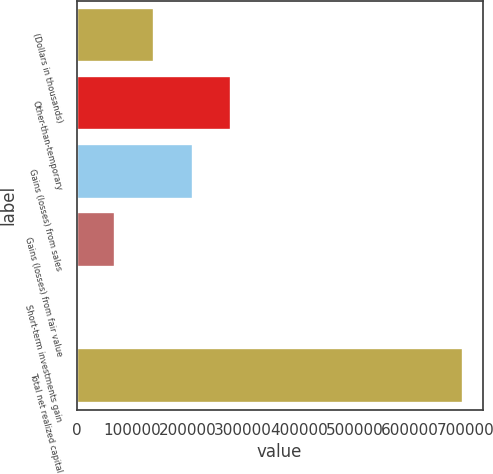<chart> <loc_0><loc_0><loc_500><loc_500><bar_chart><fcel>(Dollars in thousands)<fcel>Other-than-temporary<fcel>Gains (losses) from sales<fcel>Gains (losses) from fair value<fcel>Short-term investments gain<fcel>Total net realized capital<nl><fcel>139271<fcel>278411<fcel>208841<fcel>69700.9<fcel>131<fcel>695830<nl></chart> 